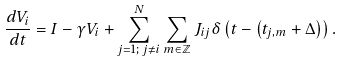Convert formula to latex. <formula><loc_0><loc_0><loc_500><loc_500>\frac { d V _ { i } } { d t } = I - \gamma V _ { i } + \sum _ { j = 1 ; \, j \neq i } ^ { N } \sum _ { m \in \mathbb { Z } } J _ { i j } \delta \left ( t - \left ( t _ { j , m } + \Delta \right ) \right ) .</formula> 